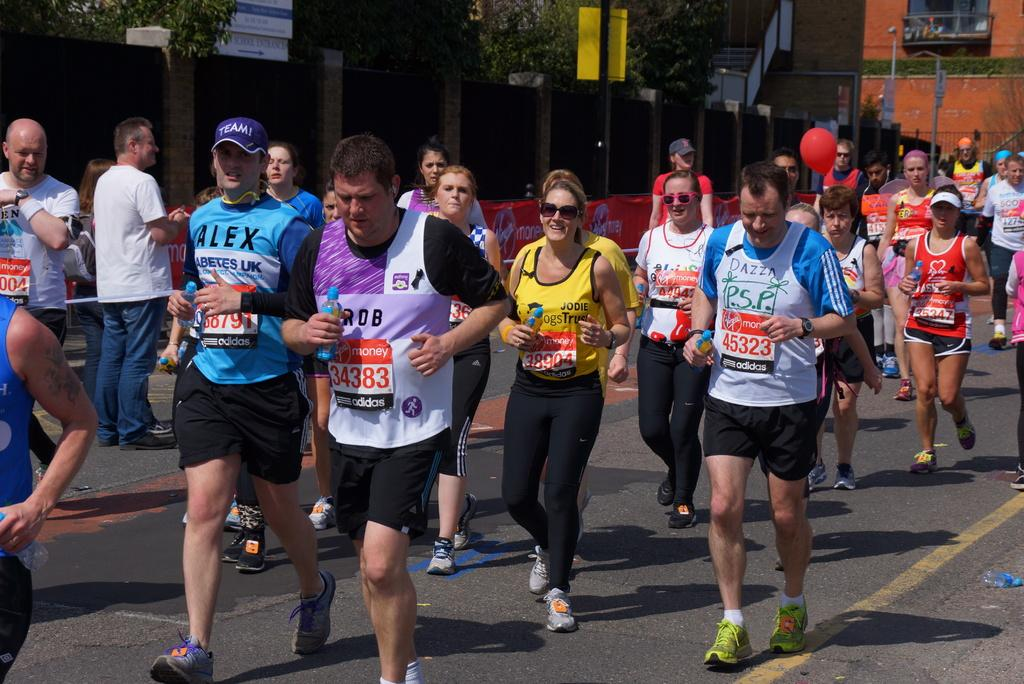What are the people in the image doing? The people in the image are running on the road. What can be seen in the background of the image? There are buildings, trees, poles, and a banner in the background. What is the size of the grandfather's hat in the image? There is no grandfather or hat present in the image. What is the weight of the person running on the right side of the image? The weight of the person running cannot be determined from the image alone. 